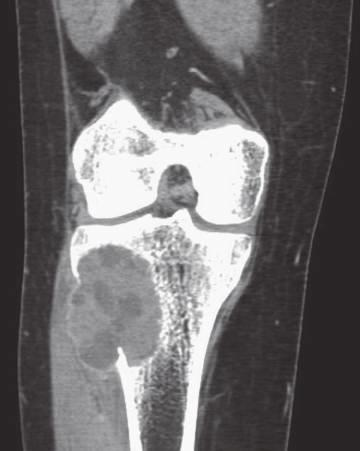does coronal computed axial tomography scan show eccentric aneurysmal bone cyst of tibia?
Answer the question using a single word or phrase. Yes 